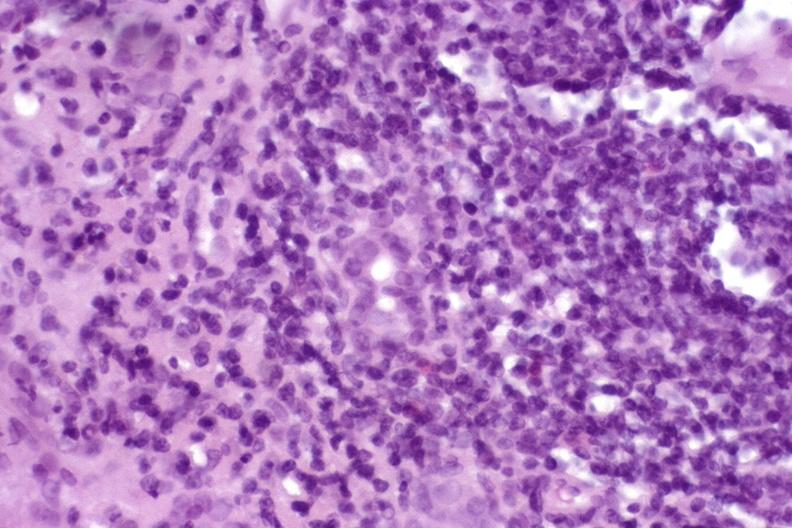what is present?
Answer the question using a single word or phrase. Hepatobiliary 